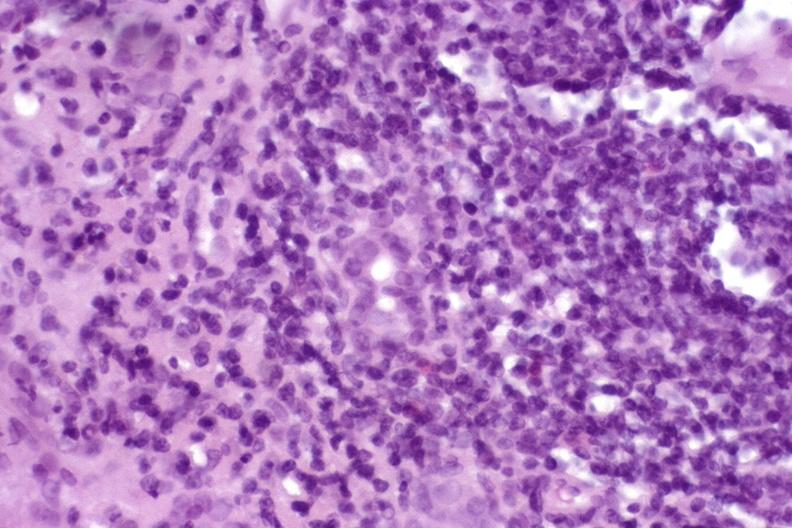what is present?
Answer the question using a single word or phrase. Hepatobiliary 